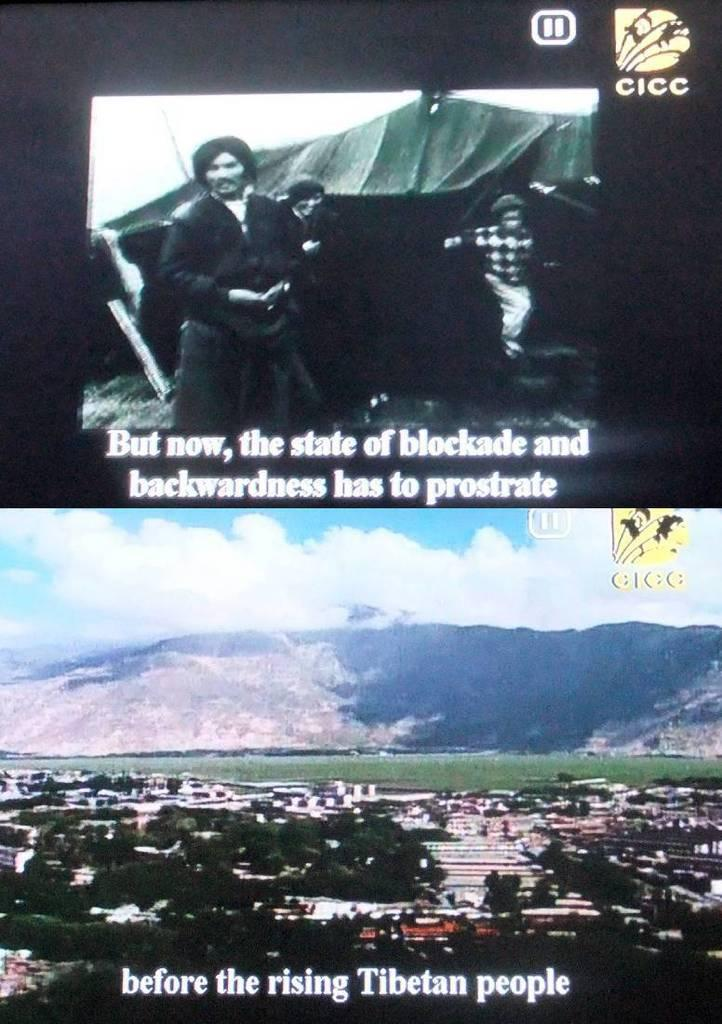<image>
Create a compact narrative representing the image presented. Two screenshots of a subtitled Asian TV show tell us about the rising of the Tibetan people. 